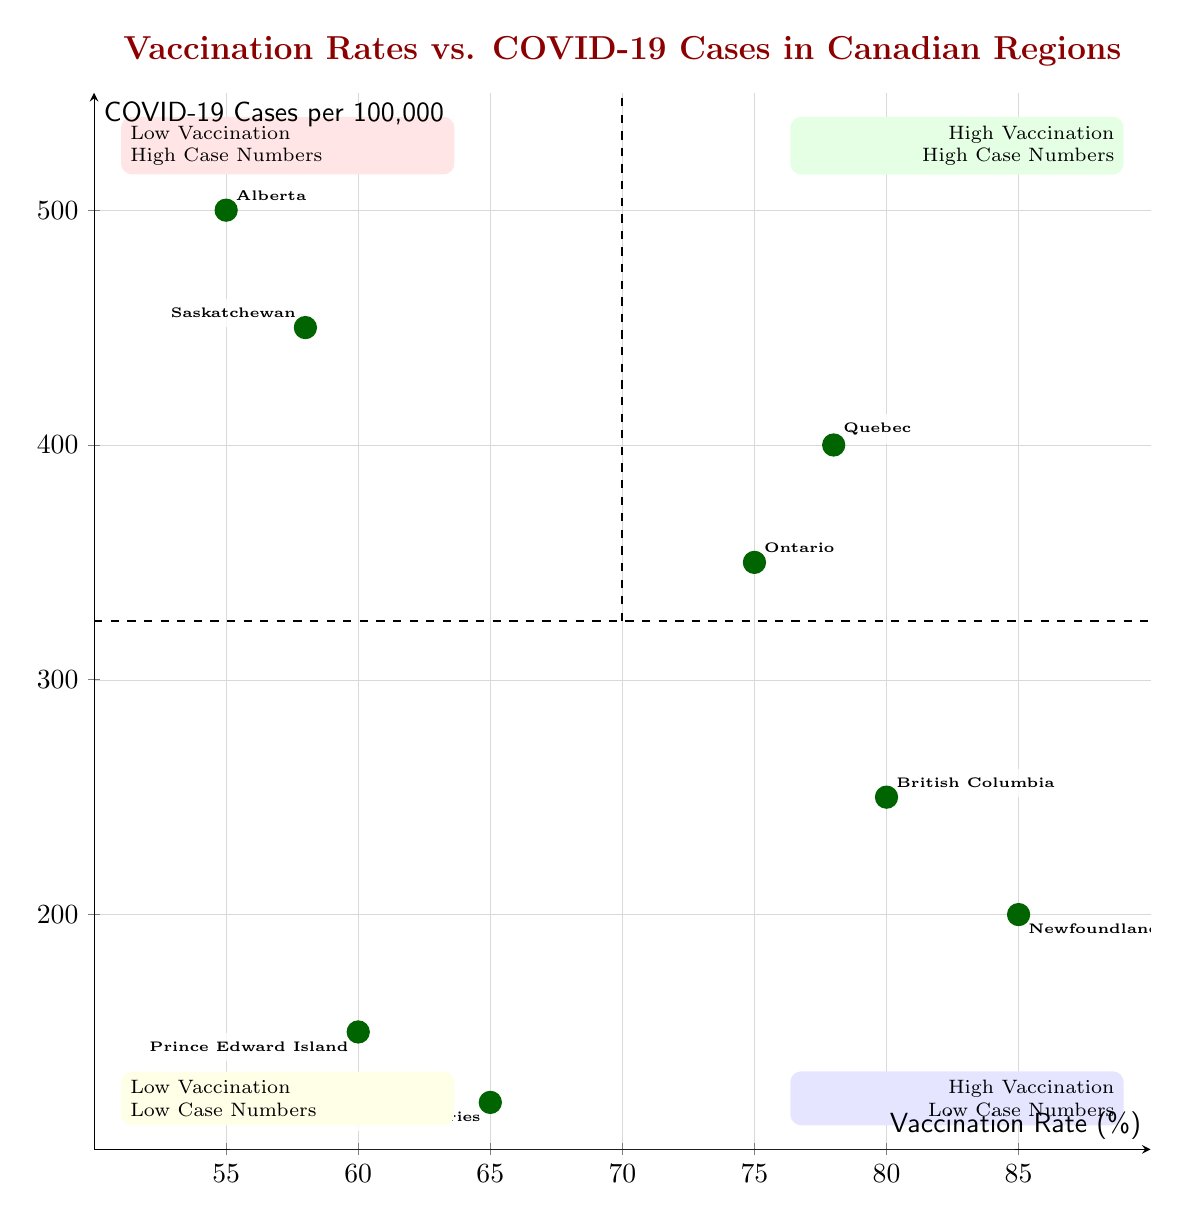What are the regions with high vaccination and low case numbers? According to the diagram, the regions located in the quadrant for high vaccination and low case numbers are British Columbia and Newfoundland and Labrador.
Answer: British Columbia, Newfoundland and Labrador Which region has the highest case numbers per capita? By examining the values represented on the y-axis, Alberta has the highest case numbers per capita with 500 per 100,000.
Answer: Alberta What is the vaccination rate for Ontario? The vaccination rate for Ontario is indicated on the plot and is displayed as 75%.
Answer: 75% How many regions fall into the low vaccination and high case numbers category? The diagram indicates two regions, Alberta and Saskatchewan, which place them into the low vaccination and high case numbers quadrant.
Answer: 2 Is there a trend identified in this chart regarding vaccination rates and COVID-19 case numbers? The text in the plot mentions a correlation between vaccination rates and case numbers being unclear, indicating that higher vaccination does not always lead to lower case numbers.
Answer: Unclear Which region has the lowest vaccination rate? By analyzing the data points labeled in the diagram, Alberta has the lowest recorded vaccination rate at 55%.
Answer: Alberta What quadrant is Prince Edward Island located in? The location of Prince Edward Island can be identified on the diagram, and it falls into the low vaccination and low case numbers quadrant.
Answer: Low Vaccination - Low Case Numbers What is the case numbers per capita for Newfoundland and Labrador? The annotation on the graph shows that Newfoundland and Labrador has case numbers per capita recorded as 200 per 100,000.
Answer: 200/100,000 How does the vaccination rate of Quebec compare to that of British Columbia? Comparing the two, Quebec has a vaccination rate of 78%, while British Columbia has a rate of 80%, showing that British Columbia has a slightly higher vaccination rate.
Answer: British Columbia higher 